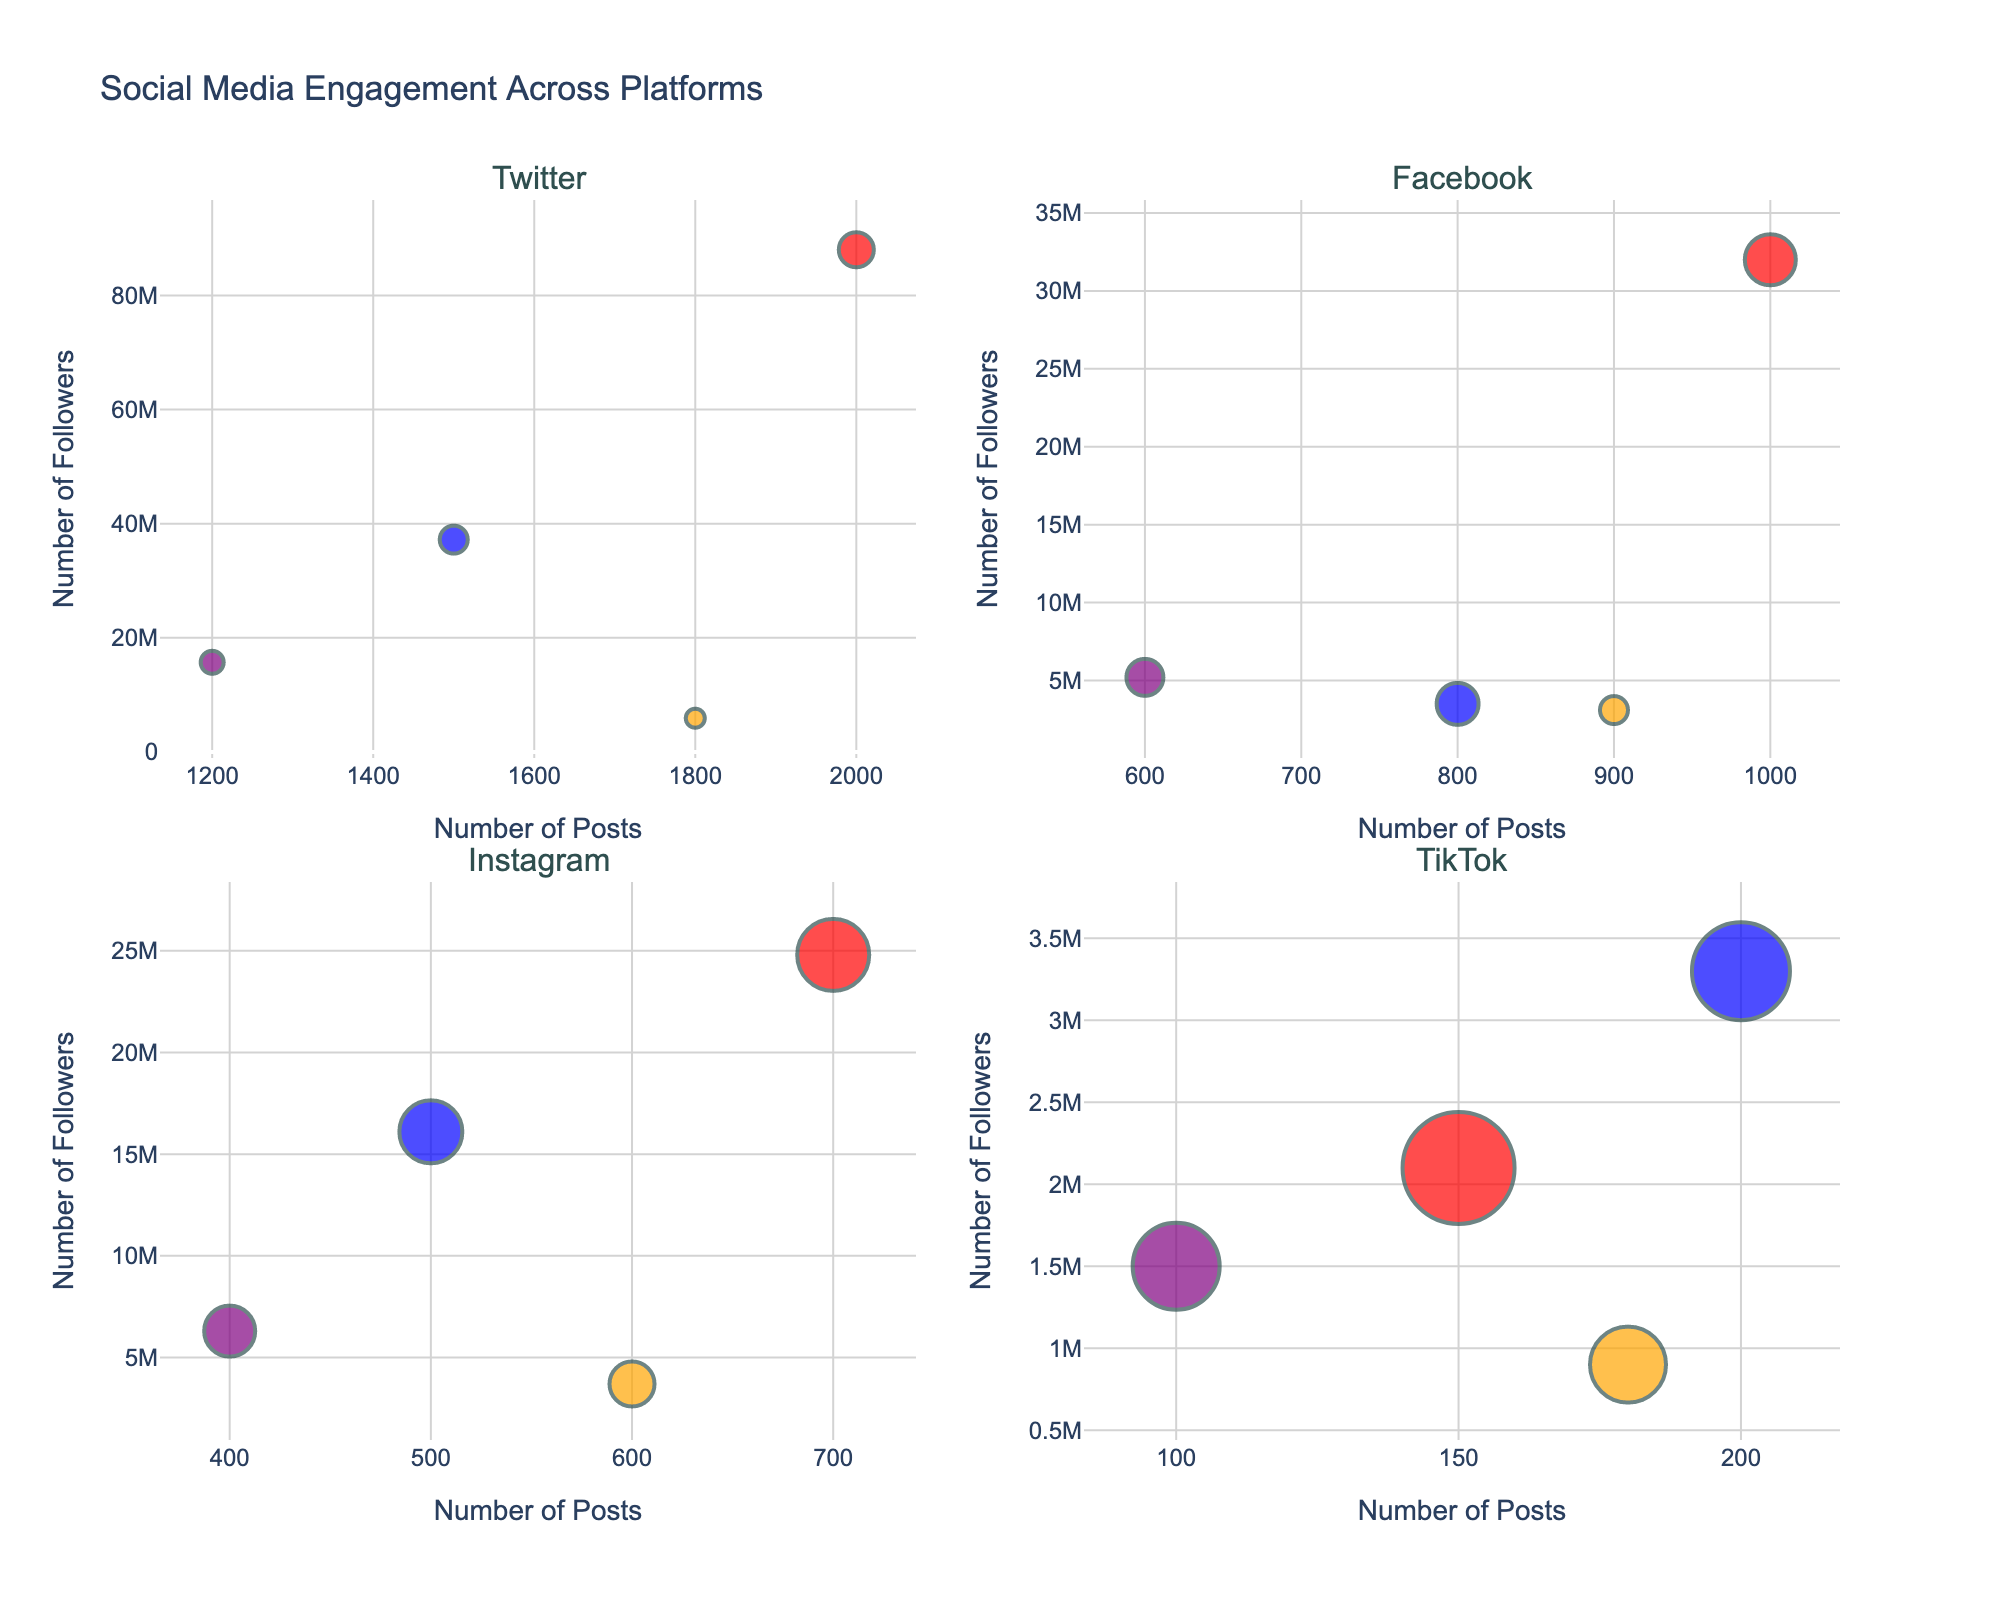Which platform has the highest engagement rate for Donald Trump? Look for the bubble representing Donald Trump in each subplot. The bubble with the largest size indicates the highest engagement rate. On TikTok, Donald Trump has the highest engagement rate.
Answer: TikTok Which candidate has the highest number of followers on Twitter? Locate the subchart for Twitter and identify the bubble that is farthest along the y-axis, representing the highest number of followers. Donald Trump's bubble is the highest on the y-axis for Twitter.
Answer: Donald Trump How does Joe Biden's engagement rate on Facebook compare to Donald Trump's on the same platform? Find the subchart for Facebook and compare the sizes of the bubbles for Joe Biden and Donald Trump. Donald Trump's bubble is larger, indicating a higher engagement rate.
Answer: Trump's engagement rate is higher Which platform has the lowest engagement rate for Elizabeth Warren? Examine all subcharts to find Elizabeth Warren's bubbles. The smallest bubble represents the lowest engagement rate. The smallest bubble for Elizabeth Warren appears in the Twitter subchart.
Answer: Twitter Who's more active on Instagram in terms of posts, Joe Biden or Donald Trump? In the Instagram subchart, compare the positions of Joe Biden's and Donald Trump's bubbles along the x-axis, which represents the number of posts. Donald Trump's bubble is farther along the x-axis, indicating more posts.
Answer: Donald Trump Which platform has the highest number of posts made by Bernie Sanders? In each subchart, locate Bernie Sanders' bubble and identify which one is farthest along the x-axis, representing the highest number of posts. The Twitter subchart shows the furthest bubble along the x-axis for Bernie Sanders.
Answer: Twitter What is the total number of posts made by Joe Biden across all platforms? Add the number of posts by Joe Biden in each subplot: Twitter (1500), Facebook (800), Instagram (500), TikTok (200). The sum is 1500 + 800 + 500 + 200.
Answer: 3000 How do the engagement rates for Bernie Sanders on Instagram and TikTok compare? Compare the sizes of Bernie Sanders' bubbles in the Instagram and TikTok subcharts. The bubble size in the TikTok subchart is larger, indicating a higher engagement rate.
Answer: Higher on TikTok Among all platforms, which has the smallest number of followers for any candidate? Find the smallest y-axis value (number of followers) for any bubble in all subcharts. Elizabeth Warren's bubble on TikTok has the smallest y-axis value, indicating the fewest followers.
Answer: TikTok What is the difference in follower count between Joe Biden and Bernie Sanders on Facebook? In the Facebook subchart, identify and compare the y-axis values for Joe Biden and Bernie Sanders. Joe Biden has 3,500,000 followers, and Bernie Sanders has 5,200,000 followers. The difference is 5,200,000 - 3,500,000.
Answer: 1,700,000 